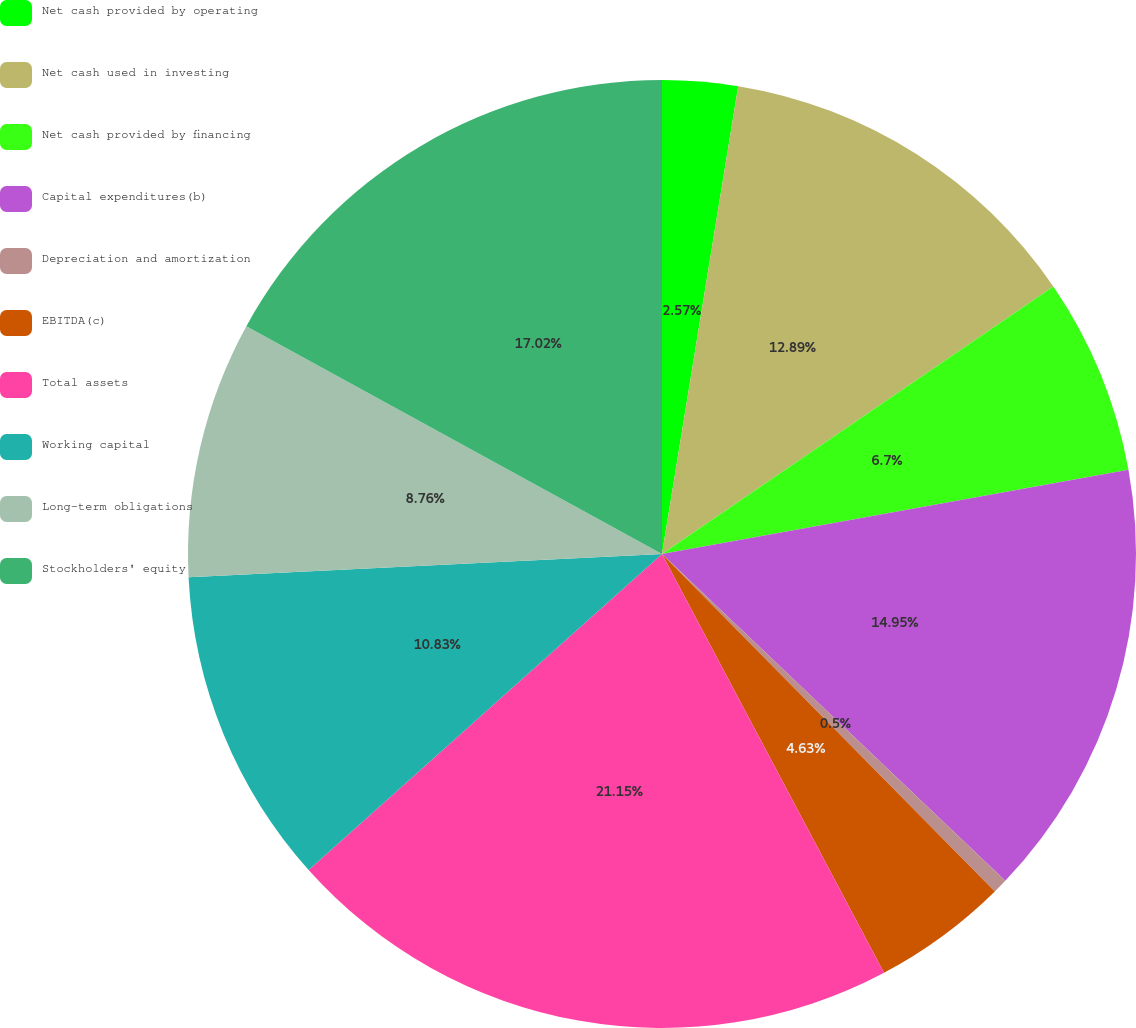<chart> <loc_0><loc_0><loc_500><loc_500><pie_chart><fcel>Net cash provided by operating<fcel>Net cash used in investing<fcel>Net cash provided by financing<fcel>Capital expenditures(b)<fcel>Depreciation and amortization<fcel>EBITDA(c)<fcel>Total assets<fcel>Working capital<fcel>Long-term obligations<fcel>Stockholders' equity<nl><fcel>2.57%<fcel>12.89%<fcel>6.7%<fcel>14.95%<fcel>0.5%<fcel>4.63%<fcel>21.15%<fcel>10.83%<fcel>8.76%<fcel>17.02%<nl></chart> 